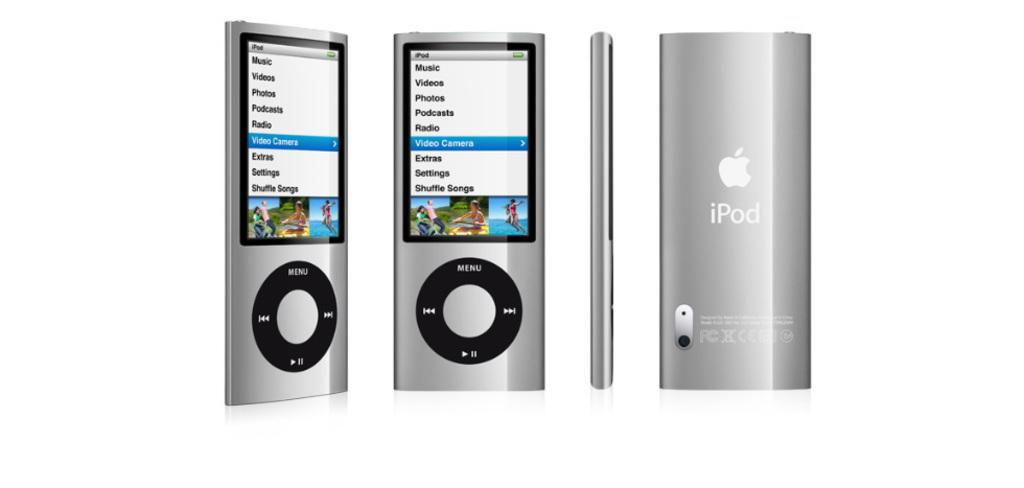<image>
Share a concise interpretation of the image provided. A silver iPod that is on its main menu hovering over the Video Camera option. 